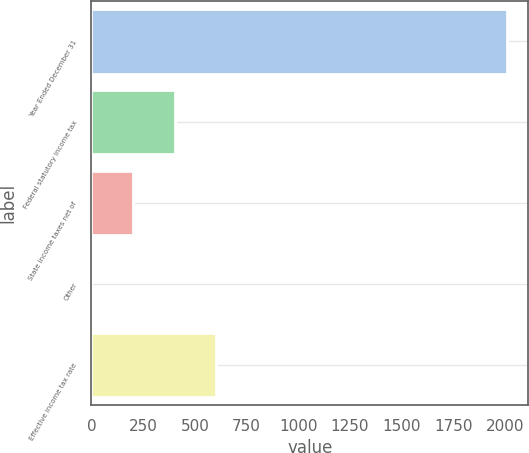<chart> <loc_0><loc_0><loc_500><loc_500><bar_chart><fcel>Year Ended December 31<fcel>Federal statutory income tax<fcel>State income taxes net of<fcel>Other<fcel>Effective income tax rate<nl><fcel>2011<fcel>402.52<fcel>201.46<fcel>0.4<fcel>603.58<nl></chart> 